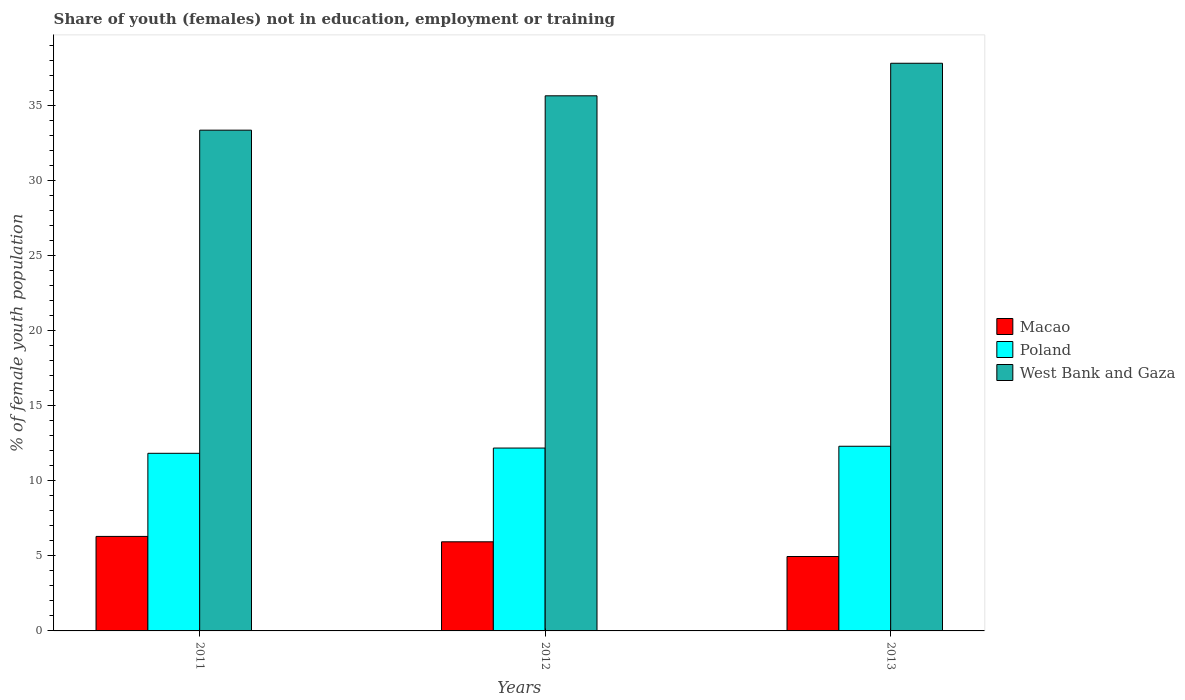How many different coloured bars are there?
Your response must be concise. 3. How many groups of bars are there?
Your answer should be very brief. 3. Are the number of bars on each tick of the X-axis equal?
Ensure brevity in your answer.  Yes. How many bars are there on the 3rd tick from the left?
Your answer should be compact. 3. In how many cases, is the number of bars for a given year not equal to the number of legend labels?
Keep it short and to the point. 0. What is the percentage of unemployed female population in in Poland in 2013?
Offer a terse response. 12.31. Across all years, what is the maximum percentage of unemployed female population in in West Bank and Gaza?
Ensure brevity in your answer.  37.84. Across all years, what is the minimum percentage of unemployed female population in in Poland?
Your answer should be compact. 11.84. What is the total percentage of unemployed female population in in Poland in the graph?
Keep it short and to the point. 36.34. What is the difference between the percentage of unemployed female population in in West Bank and Gaza in 2012 and that in 2013?
Ensure brevity in your answer.  -2.17. What is the difference between the percentage of unemployed female population in in Macao in 2011 and the percentage of unemployed female population in in Poland in 2012?
Your response must be concise. -5.89. What is the average percentage of unemployed female population in in Macao per year?
Offer a very short reply. 5.73. In the year 2013, what is the difference between the percentage of unemployed female population in in West Bank and Gaza and percentage of unemployed female population in in Macao?
Keep it short and to the point. 32.88. In how many years, is the percentage of unemployed female population in in Macao greater than 11 %?
Offer a terse response. 0. What is the ratio of the percentage of unemployed female population in in West Bank and Gaza in 2011 to that in 2012?
Keep it short and to the point. 0.94. Is the difference between the percentage of unemployed female population in in West Bank and Gaza in 2011 and 2013 greater than the difference between the percentage of unemployed female population in in Macao in 2011 and 2013?
Ensure brevity in your answer.  No. What is the difference between the highest and the second highest percentage of unemployed female population in in West Bank and Gaza?
Provide a short and direct response. 2.17. What is the difference between the highest and the lowest percentage of unemployed female population in in Macao?
Offer a terse response. 1.34. Is the sum of the percentage of unemployed female population in in West Bank and Gaza in 2012 and 2013 greater than the maximum percentage of unemployed female population in in Macao across all years?
Your response must be concise. Yes. What does the 1st bar from the right in 2012 represents?
Your answer should be compact. West Bank and Gaza. Are all the bars in the graph horizontal?
Your answer should be very brief. No. How many years are there in the graph?
Your response must be concise. 3. What is the difference between two consecutive major ticks on the Y-axis?
Your answer should be very brief. 5. Does the graph contain any zero values?
Offer a very short reply. No. Does the graph contain grids?
Provide a succinct answer. No. How many legend labels are there?
Ensure brevity in your answer.  3. How are the legend labels stacked?
Your answer should be very brief. Vertical. What is the title of the graph?
Your response must be concise. Share of youth (females) not in education, employment or training. Does "Cambodia" appear as one of the legend labels in the graph?
Make the answer very short. No. What is the label or title of the X-axis?
Provide a short and direct response. Years. What is the label or title of the Y-axis?
Give a very brief answer. % of female youth population. What is the % of female youth population in Macao in 2011?
Your response must be concise. 6.3. What is the % of female youth population of Poland in 2011?
Your response must be concise. 11.84. What is the % of female youth population of West Bank and Gaza in 2011?
Give a very brief answer. 33.38. What is the % of female youth population of Macao in 2012?
Offer a very short reply. 5.94. What is the % of female youth population in Poland in 2012?
Ensure brevity in your answer.  12.19. What is the % of female youth population of West Bank and Gaza in 2012?
Your response must be concise. 35.67. What is the % of female youth population in Macao in 2013?
Your answer should be very brief. 4.96. What is the % of female youth population of Poland in 2013?
Your answer should be very brief. 12.31. What is the % of female youth population of West Bank and Gaza in 2013?
Ensure brevity in your answer.  37.84. Across all years, what is the maximum % of female youth population of Macao?
Your response must be concise. 6.3. Across all years, what is the maximum % of female youth population in Poland?
Ensure brevity in your answer.  12.31. Across all years, what is the maximum % of female youth population of West Bank and Gaza?
Your response must be concise. 37.84. Across all years, what is the minimum % of female youth population in Macao?
Make the answer very short. 4.96. Across all years, what is the minimum % of female youth population of Poland?
Give a very brief answer. 11.84. Across all years, what is the minimum % of female youth population of West Bank and Gaza?
Provide a short and direct response. 33.38. What is the total % of female youth population in Macao in the graph?
Provide a succinct answer. 17.2. What is the total % of female youth population of Poland in the graph?
Your answer should be very brief. 36.34. What is the total % of female youth population of West Bank and Gaza in the graph?
Your answer should be very brief. 106.89. What is the difference between the % of female youth population in Macao in 2011 and that in 2012?
Provide a short and direct response. 0.36. What is the difference between the % of female youth population of Poland in 2011 and that in 2012?
Keep it short and to the point. -0.35. What is the difference between the % of female youth population of West Bank and Gaza in 2011 and that in 2012?
Your response must be concise. -2.29. What is the difference between the % of female youth population in Macao in 2011 and that in 2013?
Provide a succinct answer. 1.34. What is the difference between the % of female youth population of Poland in 2011 and that in 2013?
Give a very brief answer. -0.47. What is the difference between the % of female youth population in West Bank and Gaza in 2011 and that in 2013?
Your response must be concise. -4.46. What is the difference between the % of female youth population in Poland in 2012 and that in 2013?
Offer a very short reply. -0.12. What is the difference between the % of female youth population in West Bank and Gaza in 2012 and that in 2013?
Provide a short and direct response. -2.17. What is the difference between the % of female youth population in Macao in 2011 and the % of female youth population in Poland in 2012?
Your answer should be very brief. -5.89. What is the difference between the % of female youth population of Macao in 2011 and the % of female youth population of West Bank and Gaza in 2012?
Offer a terse response. -29.37. What is the difference between the % of female youth population of Poland in 2011 and the % of female youth population of West Bank and Gaza in 2012?
Ensure brevity in your answer.  -23.83. What is the difference between the % of female youth population of Macao in 2011 and the % of female youth population of Poland in 2013?
Give a very brief answer. -6.01. What is the difference between the % of female youth population in Macao in 2011 and the % of female youth population in West Bank and Gaza in 2013?
Your answer should be very brief. -31.54. What is the difference between the % of female youth population of Poland in 2011 and the % of female youth population of West Bank and Gaza in 2013?
Provide a succinct answer. -26. What is the difference between the % of female youth population of Macao in 2012 and the % of female youth population of Poland in 2013?
Provide a short and direct response. -6.37. What is the difference between the % of female youth population in Macao in 2012 and the % of female youth population in West Bank and Gaza in 2013?
Make the answer very short. -31.9. What is the difference between the % of female youth population of Poland in 2012 and the % of female youth population of West Bank and Gaza in 2013?
Make the answer very short. -25.65. What is the average % of female youth population in Macao per year?
Offer a terse response. 5.73. What is the average % of female youth population in Poland per year?
Keep it short and to the point. 12.11. What is the average % of female youth population of West Bank and Gaza per year?
Your response must be concise. 35.63. In the year 2011, what is the difference between the % of female youth population in Macao and % of female youth population in Poland?
Offer a terse response. -5.54. In the year 2011, what is the difference between the % of female youth population of Macao and % of female youth population of West Bank and Gaza?
Make the answer very short. -27.08. In the year 2011, what is the difference between the % of female youth population of Poland and % of female youth population of West Bank and Gaza?
Offer a very short reply. -21.54. In the year 2012, what is the difference between the % of female youth population in Macao and % of female youth population in Poland?
Your answer should be very brief. -6.25. In the year 2012, what is the difference between the % of female youth population in Macao and % of female youth population in West Bank and Gaza?
Your response must be concise. -29.73. In the year 2012, what is the difference between the % of female youth population of Poland and % of female youth population of West Bank and Gaza?
Your answer should be very brief. -23.48. In the year 2013, what is the difference between the % of female youth population in Macao and % of female youth population in Poland?
Offer a very short reply. -7.35. In the year 2013, what is the difference between the % of female youth population of Macao and % of female youth population of West Bank and Gaza?
Offer a very short reply. -32.88. In the year 2013, what is the difference between the % of female youth population in Poland and % of female youth population in West Bank and Gaza?
Give a very brief answer. -25.53. What is the ratio of the % of female youth population in Macao in 2011 to that in 2012?
Your answer should be very brief. 1.06. What is the ratio of the % of female youth population in Poland in 2011 to that in 2012?
Your response must be concise. 0.97. What is the ratio of the % of female youth population in West Bank and Gaza in 2011 to that in 2012?
Your answer should be very brief. 0.94. What is the ratio of the % of female youth population of Macao in 2011 to that in 2013?
Keep it short and to the point. 1.27. What is the ratio of the % of female youth population of Poland in 2011 to that in 2013?
Ensure brevity in your answer.  0.96. What is the ratio of the % of female youth population of West Bank and Gaza in 2011 to that in 2013?
Offer a terse response. 0.88. What is the ratio of the % of female youth population of Macao in 2012 to that in 2013?
Give a very brief answer. 1.2. What is the ratio of the % of female youth population in Poland in 2012 to that in 2013?
Your answer should be compact. 0.99. What is the ratio of the % of female youth population of West Bank and Gaza in 2012 to that in 2013?
Your response must be concise. 0.94. What is the difference between the highest and the second highest % of female youth population in Macao?
Keep it short and to the point. 0.36. What is the difference between the highest and the second highest % of female youth population in Poland?
Keep it short and to the point. 0.12. What is the difference between the highest and the second highest % of female youth population in West Bank and Gaza?
Your response must be concise. 2.17. What is the difference between the highest and the lowest % of female youth population of Macao?
Provide a short and direct response. 1.34. What is the difference between the highest and the lowest % of female youth population of Poland?
Provide a succinct answer. 0.47. What is the difference between the highest and the lowest % of female youth population of West Bank and Gaza?
Give a very brief answer. 4.46. 